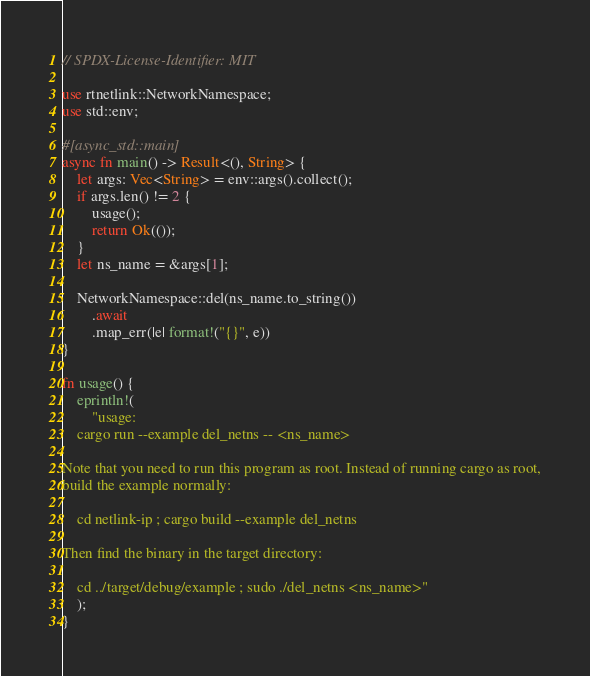Convert code to text. <code><loc_0><loc_0><loc_500><loc_500><_Rust_>// SPDX-License-Identifier: MIT

use rtnetlink::NetworkNamespace;
use std::env;

#[async_std::main]
async fn main() -> Result<(), String> {
    let args: Vec<String> = env::args().collect();
    if args.len() != 2 {
        usage();
        return Ok(());
    }
    let ns_name = &args[1];

    NetworkNamespace::del(ns_name.to_string())
        .await
        .map_err(|e| format!("{}", e))
}

fn usage() {
    eprintln!(
        "usage:
    cargo run --example del_netns -- <ns_name>

Note that you need to run this program as root. Instead of running cargo as root,
build the example normally:

    cd netlink-ip ; cargo build --example del_netns

Then find the binary in the target directory:

    cd ../target/debug/example ; sudo ./del_netns <ns_name>"
    );
}
</code> 